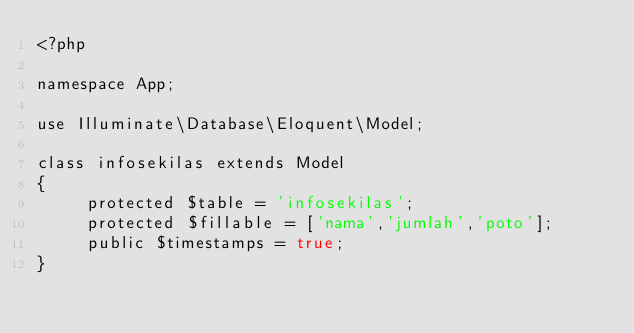Convert code to text. <code><loc_0><loc_0><loc_500><loc_500><_PHP_><?php

namespace App;

use Illuminate\Database\Eloquent\Model;

class infosekilas extends Model
{
     protected $table = 'infosekilas';
     protected $fillable = ['nama','jumlah','poto'];
     public $timestamps = true;
}
</code> 